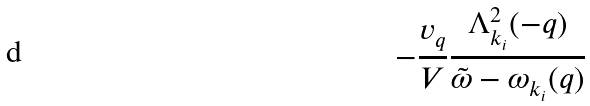Convert formula to latex. <formula><loc_0><loc_0><loc_500><loc_500>- \frac { v _ { q } } { V } \frac { \Lambda ^ { 2 } _ { { k } _ { i } } ( - { q } ) } { { \tilde { \omega } } - \omega _ { { k } _ { i } } ( { q } ) }</formula> 